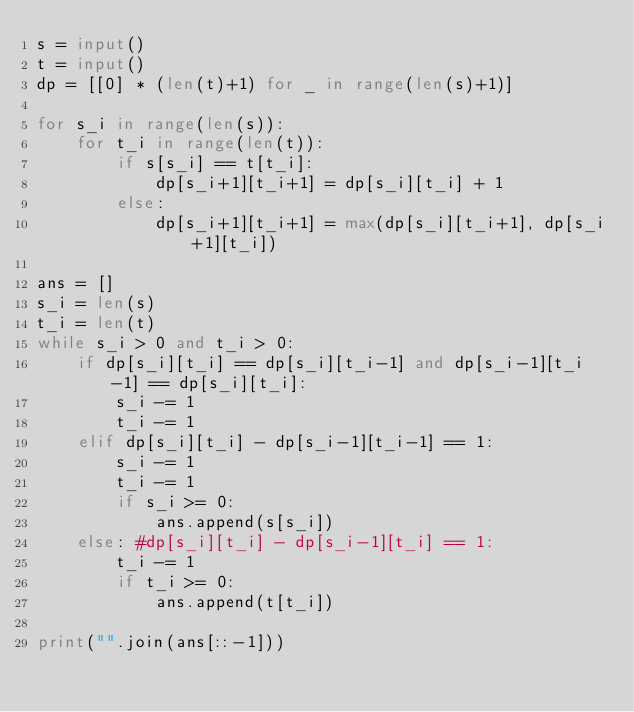Convert code to text. <code><loc_0><loc_0><loc_500><loc_500><_Python_>s = input()
t = input()
dp = [[0] * (len(t)+1) for _ in range(len(s)+1)]

for s_i in range(len(s)):
    for t_i in range(len(t)):
        if s[s_i] == t[t_i]:
            dp[s_i+1][t_i+1] = dp[s_i][t_i] + 1
        else:
            dp[s_i+1][t_i+1] = max(dp[s_i][t_i+1], dp[s_i+1][t_i])

ans = []
s_i = len(s)
t_i = len(t)
while s_i > 0 and t_i > 0:
    if dp[s_i][t_i] == dp[s_i][t_i-1] and dp[s_i-1][t_i-1] == dp[s_i][t_i]:
        s_i -= 1
        t_i -= 1
    elif dp[s_i][t_i] - dp[s_i-1][t_i-1] == 1:
        s_i -= 1
        t_i -= 1
        if s_i >= 0:
            ans.append(s[s_i])
    else: #dp[s_i][t_i] - dp[s_i-1][t_i] == 1:
        t_i -= 1
        if t_i >= 0:
            ans.append(t[t_i])

print("".join(ans[::-1]))</code> 